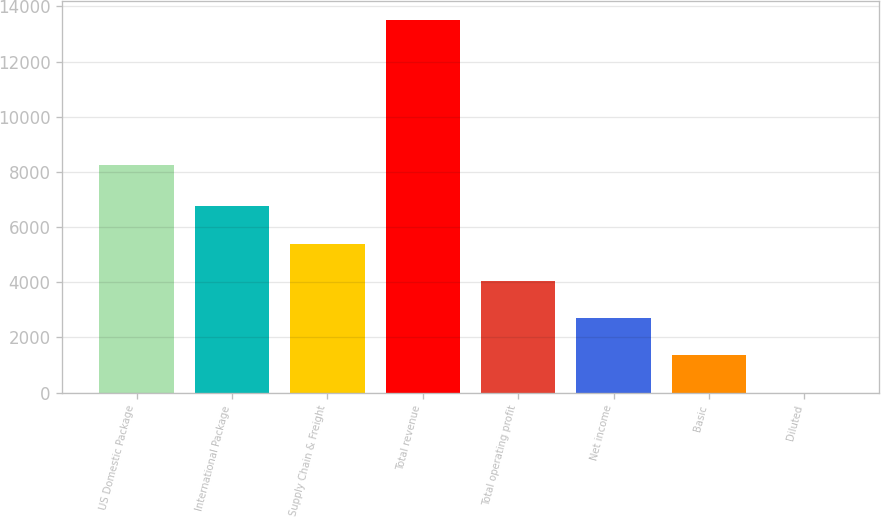<chart> <loc_0><loc_0><loc_500><loc_500><bar_chart><fcel>US Domestic Package<fcel>International Package<fcel>Supply Chain & Freight<fcel>Total revenue<fcel>Total operating profit<fcel>Net income<fcel>Basic<fcel>Diluted<nl><fcel>8241<fcel>6754.08<fcel>5403.49<fcel>13507<fcel>4052.9<fcel>2702.31<fcel>1351.72<fcel>1.13<nl></chart> 